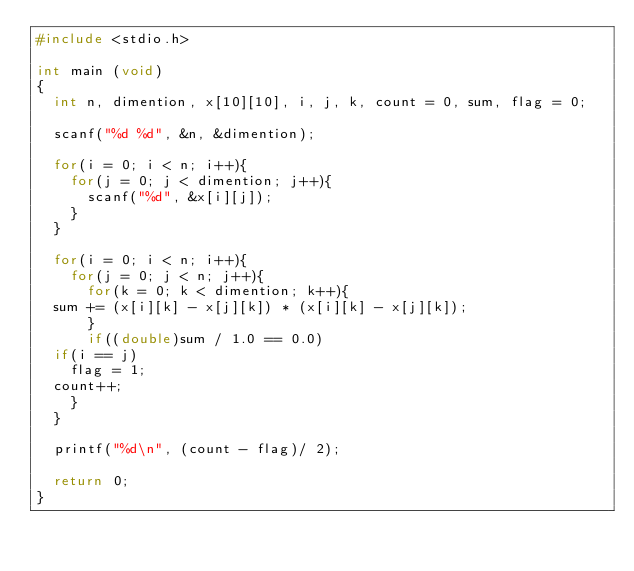<code> <loc_0><loc_0><loc_500><loc_500><_C_>#include <stdio.h>

int main (void)
{
  int n, dimention, x[10][10], i, j, k, count = 0, sum, flag = 0;

  scanf("%d %d", &n, &dimention);

  for(i = 0; i < n; i++){
    for(j = 0; j < dimention; j++){
      scanf("%d", &x[i][j]);
    }
  }

  for(i = 0; i < n; i++){
    for(j = 0; j < n; j++){
      for(k = 0; k < dimention; k++){
	sum += (x[i][k] - x[j][k]) * (x[i][k] - x[j][k]);
      }
      if((double)sum / 1.0 == 0.0)
	if(i == j)
	  flag = 1;
	count++;
    }
  }

  printf("%d\n", (count - flag)/ 2);

  return 0;
}
</code> 